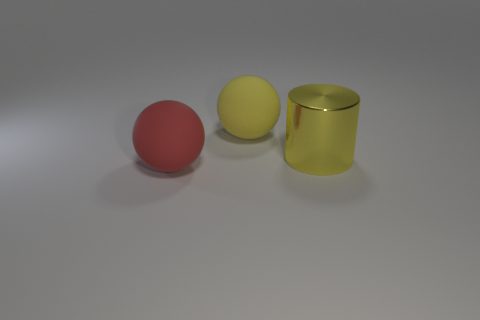Add 2 red matte balls. How many objects exist? 5 Subtract all balls. How many objects are left? 1 Subtract all red balls. How many balls are left? 1 Add 3 objects. How many objects are left? 6 Add 2 yellow metallic objects. How many yellow metallic objects exist? 3 Subtract 0 purple balls. How many objects are left? 3 Subtract all yellow balls. Subtract all brown blocks. How many balls are left? 1 Subtract all cyan metal blocks. Subtract all large objects. How many objects are left? 0 